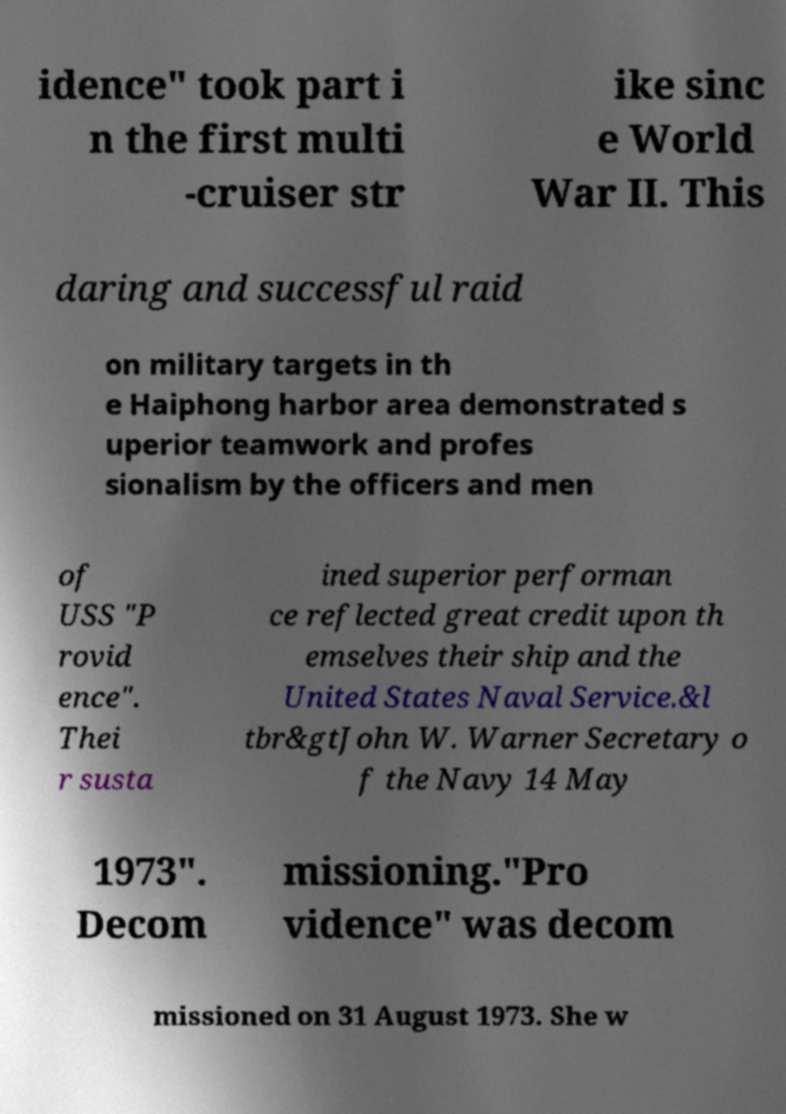What messages or text are displayed in this image? I need them in a readable, typed format. idence" took part i n the first multi -cruiser str ike sinc e World War II. This daring and successful raid on military targets in th e Haiphong harbor area demonstrated s uperior teamwork and profes sionalism by the officers and men of USS "P rovid ence". Thei r susta ined superior performan ce reflected great credit upon th emselves their ship and the United States Naval Service.&l tbr&gtJohn W. Warner Secretary o f the Navy 14 May 1973". Decom missioning."Pro vidence" was decom missioned on 31 August 1973. She w 